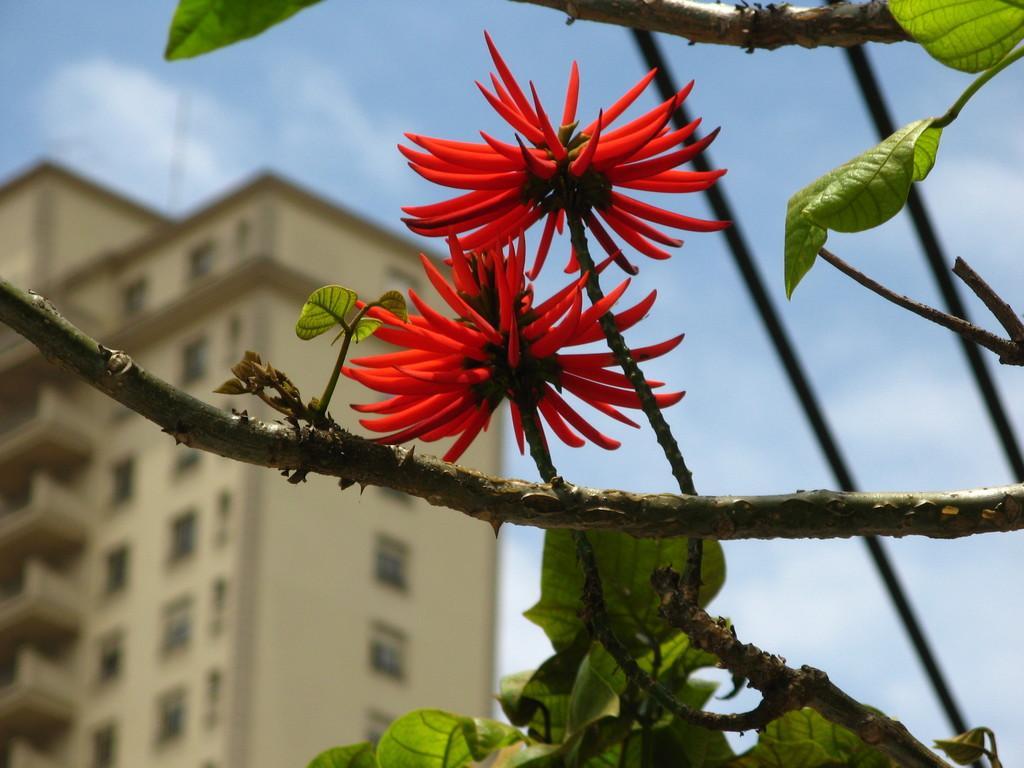Describe this image in one or two sentences. In this picture we can see two red color flowers and leaves here, in the background there is a building, we can see the sky at the top of the picture. 